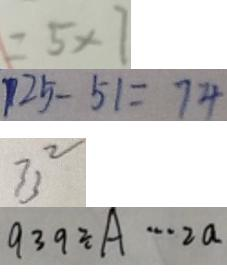Convert formula to latex. <formula><loc_0><loc_0><loc_500><loc_500>= 5 \times 7 
 1 2 5 - 5 1 = 7 4 
 3 3 ^ { 2 } 
 9 3 9 \div A \cdots 2 a</formula> 